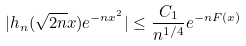Convert formula to latex. <formula><loc_0><loc_0><loc_500><loc_500>| h _ { n } ( \sqrt { 2 n } x ) e ^ { - n x ^ { 2 } } | \leq \frac { C _ { 1 } } { n ^ { 1 / 4 } } e ^ { - n F ( x ) }</formula> 